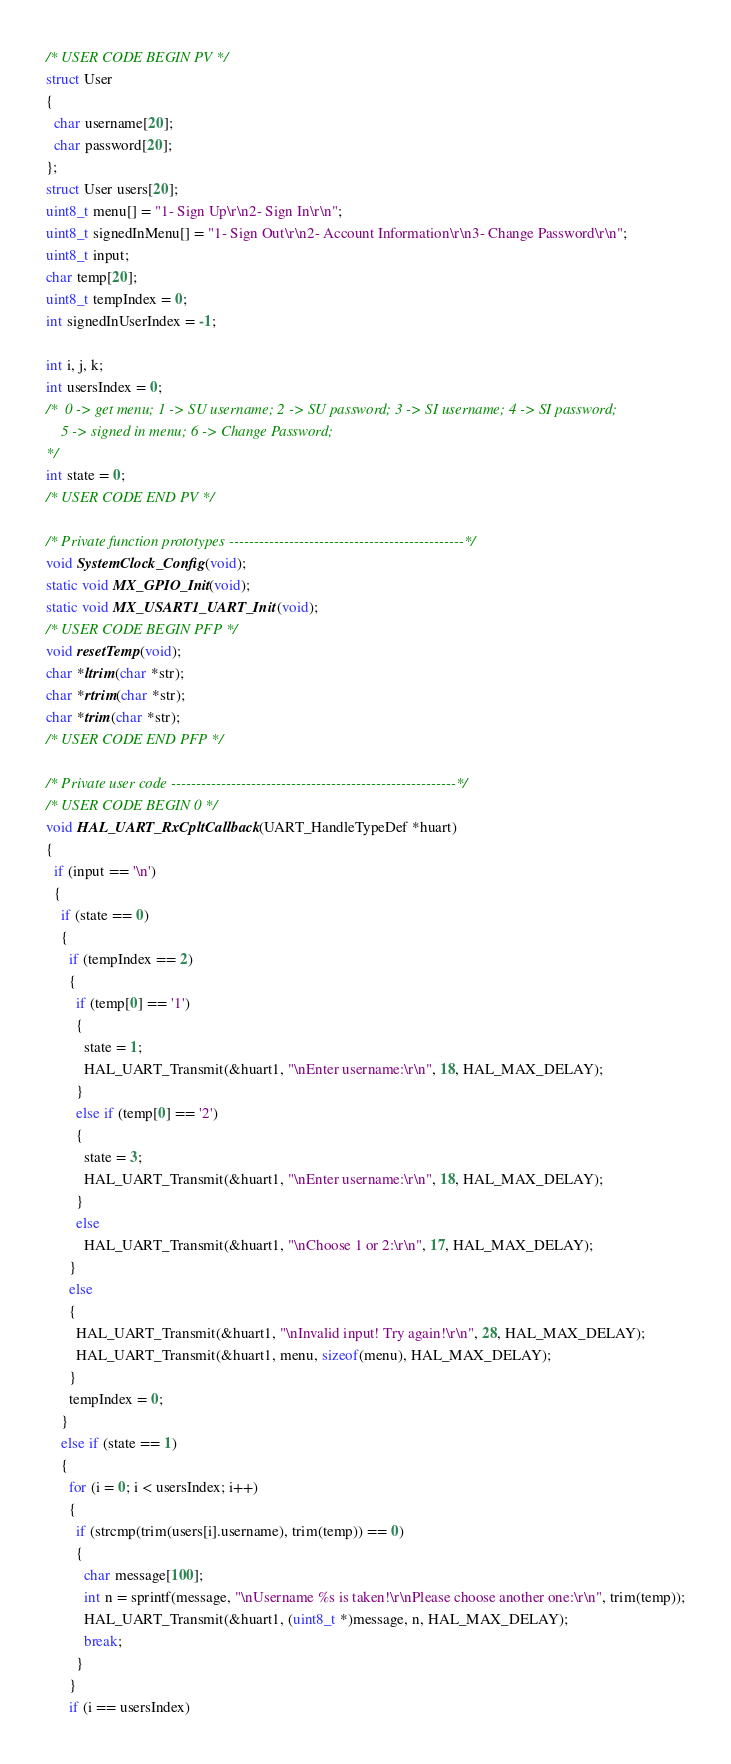<code> <loc_0><loc_0><loc_500><loc_500><_C_>/* USER CODE BEGIN PV */
struct User
{
  char username[20];
  char password[20];
};
struct User users[20];
uint8_t menu[] = "1- Sign Up\r\n2- Sign In\r\n";
uint8_t signedInMenu[] = "1- Sign Out\r\n2- Account Information\r\n3- Change Password\r\n";
uint8_t input;
char temp[20];
uint8_t tempIndex = 0;
int signedInUserIndex = -1;

int i, j, k;
int usersIndex = 0;
/*  0 -> get menu; 1 -> SU username; 2 -> SU password; 3 -> SI username; 4 -> SI password;
    5 -> signed in menu; 6 -> Change Password;
*/
int state = 0;
/* USER CODE END PV */

/* Private function prototypes -----------------------------------------------*/
void SystemClock_Config(void);
static void MX_GPIO_Init(void);
static void MX_USART1_UART_Init(void);
/* USER CODE BEGIN PFP */
void resetTemp(void);
char *ltrim(char *str);
char *rtrim(char *str);
char *trim(char *str);
/* USER CODE END PFP */

/* Private user code ---------------------------------------------------------*/
/* USER CODE BEGIN 0 */
void HAL_UART_RxCpltCallback(UART_HandleTypeDef *huart)
{
  if (input == '\n')
  {
    if (state == 0)
    {
      if (tempIndex == 2)
      {
        if (temp[0] == '1')
        {
          state = 1;
          HAL_UART_Transmit(&huart1, "\nEnter username:\r\n", 18, HAL_MAX_DELAY);
        }
        else if (temp[0] == '2')
        {
          state = 3;
          HAL_UART_Transmit(&huart1, "\nEnter username:\r\n", 18, HAL_MAX_DELAY);
        }
        else
          HAL_UART_Transmit(&huart1, "\nChoose 1 or 2:\r\n", 17, HAL_MAX_DELAY);
      }
      else
      {
        HAL_UART_Transmit(&huart1, "\nInvalid input! Try again!\r\n", 28, HAL_MAX_DELAY);
        HAL_UART_Transmit(&huart1, menu, sizeof(menu), HAL_MAX_DELAY);
      }
      tempIndex = 0;
    }
    else if (state == 1)
    {
      for (i = 0; i < usersIndex; i++)
      {
        if (strcmp(trim(users[i].username), trim(temp)) == 0)
        {
          char message[100];
          int n = sprintf(message, "\nUsername %s is taken!\r\nPlease choose another one:\r\n", trim(temp));
          HAL_UART_Transmit(&huart1, (uint8_t *)message, n, HAL_MAX_DELAY);
          break;
        }
      }
      if (i == usersIndex)</code> 